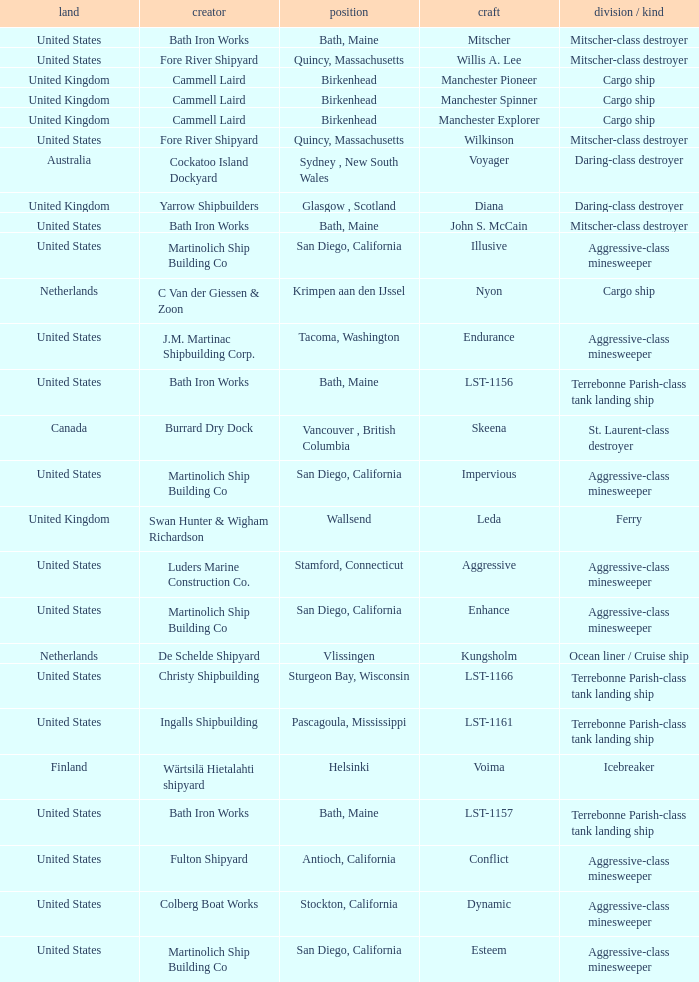What is the Cargo Ship located at Birkenhead? Manchester Pioneer, Manchester Spinner, Manchester Explorer. 